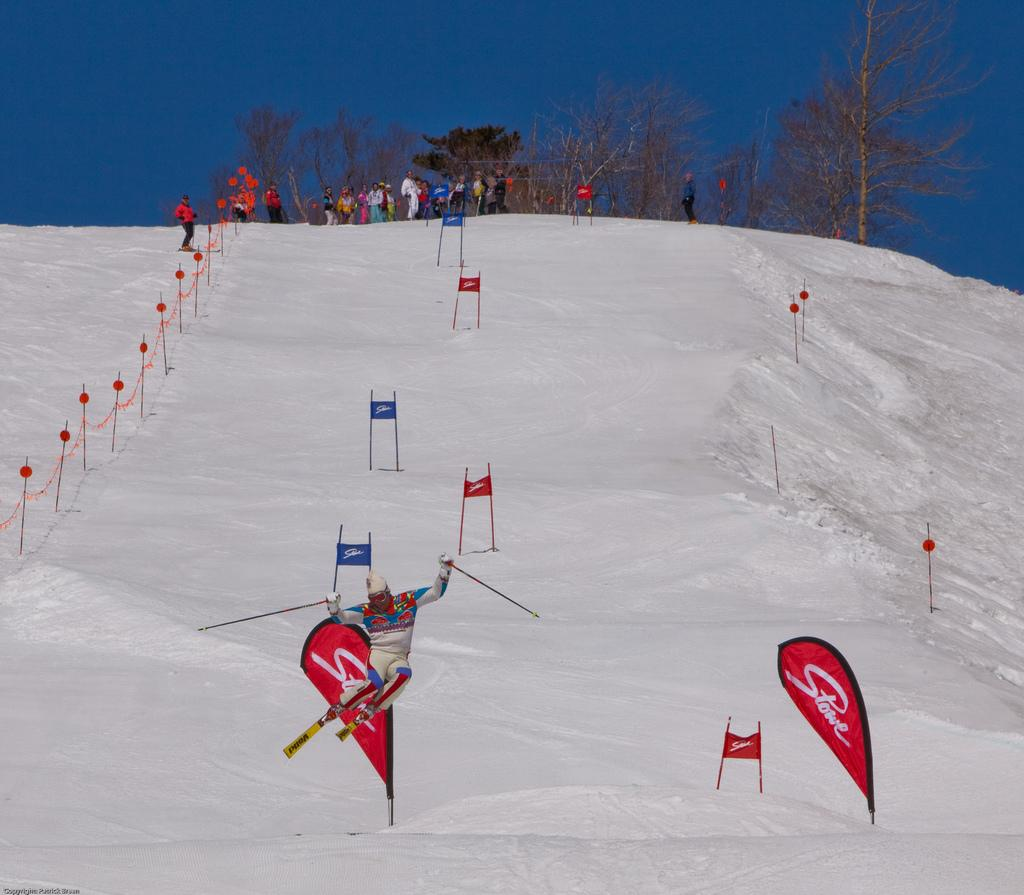<image>
Share a concise interpretation of the image provided. A skiier races down the snowy mountain near red flags that say Stowe 